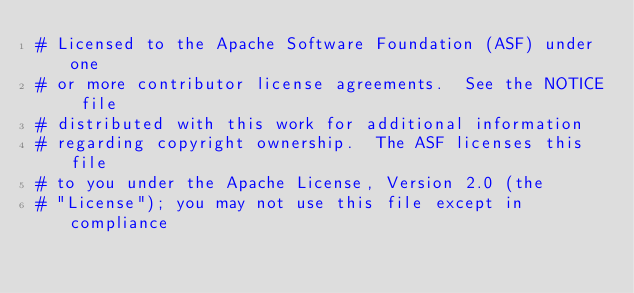Convert code to text. <code><loc_0><loc_0><loc_500><loc_500><_Cython_># Licensed to the Apache Software Foundation (ASF) under one
# or more contributor license agreements.  See the NOTICE file
# distributed with this work for additional information
# regarding copyright ownership.  The ASF licenses this file
# to you under the Apache License, Version 2.0 (the
# "License"); you may not use this file except in compliance</code> 